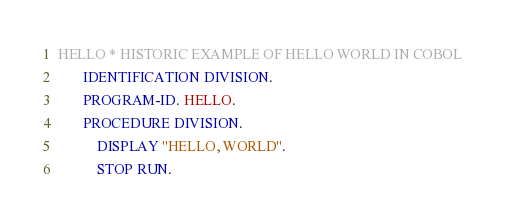Convert code to text. <code><loc_0><loc_0><loc_500><loc_500><_COBOL_>HELLO * HISTORIC EXAMPLE OF HELLO WORLD IN COBOL
       IDENTIFICATION DIVISION.
       PROGRAM-ID. HELLO.
       PROCEDURE DIVISION.
           DISPLAY "HELLO, WORLD".
           STOP RUN.
</code> 